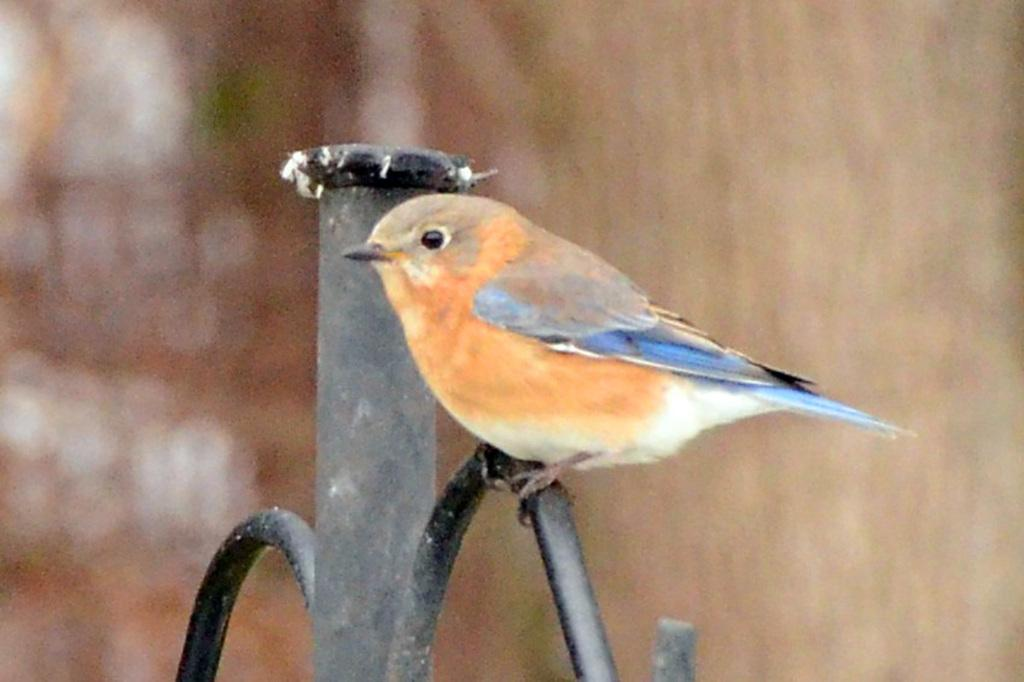What type of animal is present in the image? There is a bird in the image. Where is the bird located? The bird is on a metal stand. What type of hat is the bird wearing in the image? There is no hat present on the bird in the image. 